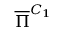<formula> <loc_0><loc_0><loc_500><loc_500>\overline { \Pi } ^ { C _ { 1 } }</formula> 